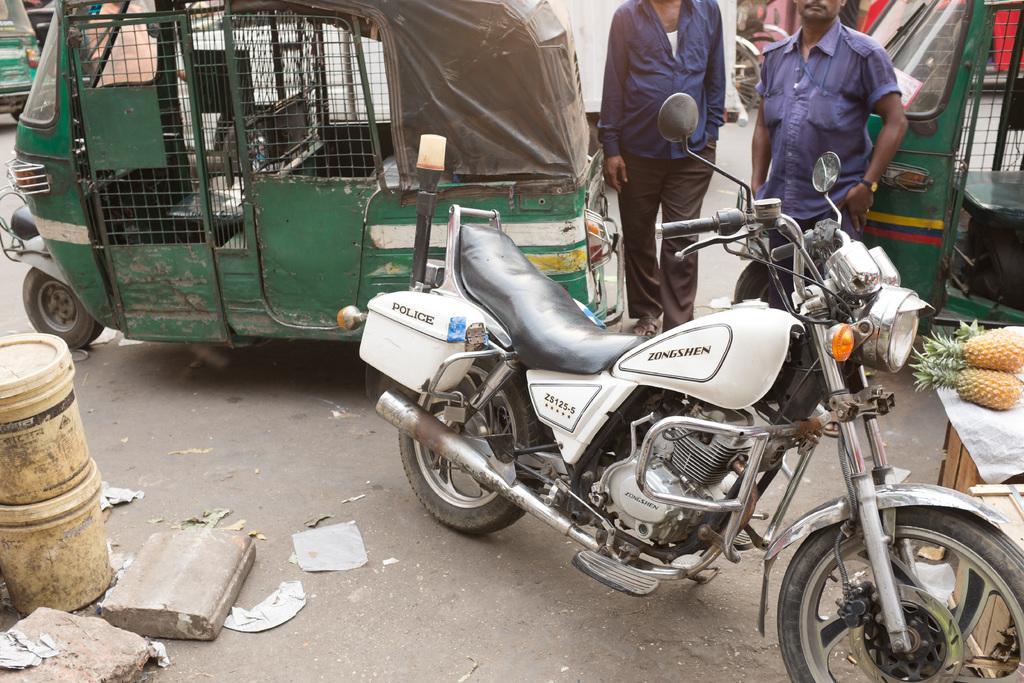Please provide a concise description of this image. In this picture we can see there are auto rickshaws, motorbike, bicycles and people on the road. On the left side of the image, there are stones and two plastic buckets. On the right side of the image, there are pineapples on an object. 